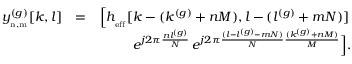Convert formula to latex. <formula><loc_0><loc_0><loc_500><loc_500>\begin{array} { r l r } { y _ { _ { n , m } } ^ { ( g ) } [ k , l ] } & { = } & { { \left [ } h _ { _ { e f f } } [ k - ( k ^ { ( g ) } + n M ) , l - ( l ^ { ( g ) } + m N ) ] \, } \\ & { \, e ^ { j 2 \pi \frac { n l ^ { ( g ) } } { N } } \, e ^ { j 2 \pi \frac { ( l - l ^ { ( g ) } - m N ) } { N } \frac { ( k ^ { ( g ) } + n M ) } { M } } { \right ] } . } \end{array}</formula> 